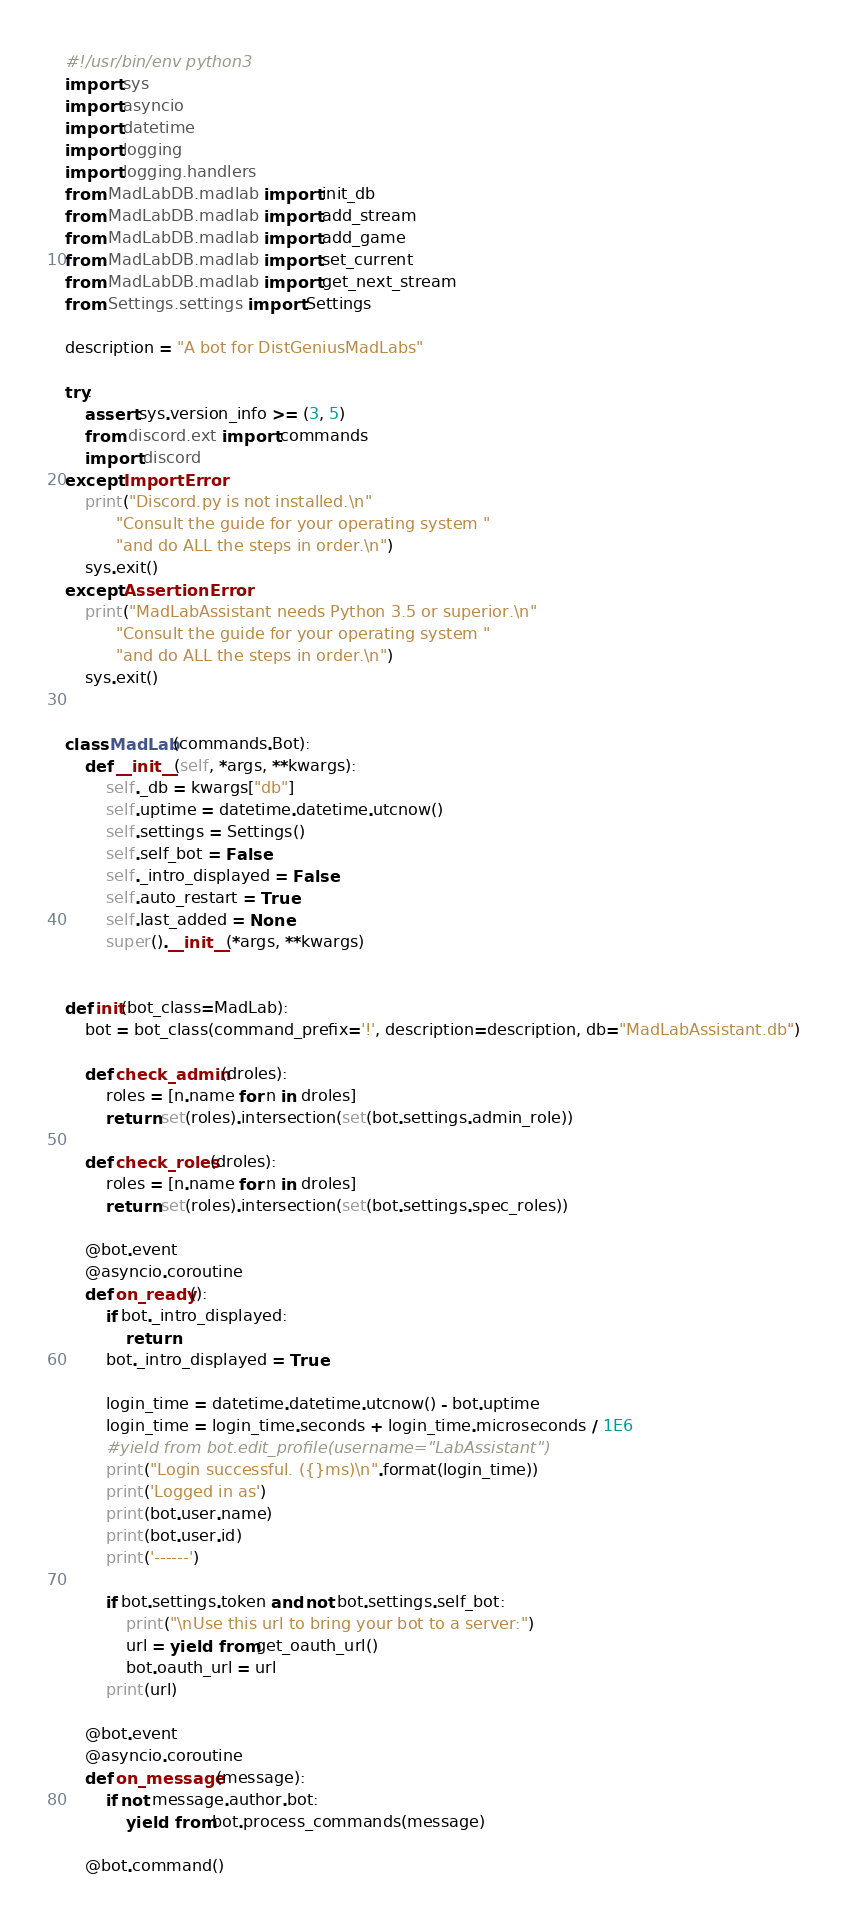<code> <loc_0><loc_0><loc_500><loc_500><_Python_>#!/usr/bin/env python3
import sys
import asyncio
import datetime
import logging
import logging.handlers
from MadLabDB.madlab import init_db
from MadLabDB.madlab import add_stream
from MadLabDB.madlab import add_game
from MadLabDB.madlab import set_current
from MadLabDB.madlab import get_next_stream
from Settings.settings import Settings

description = "A bot for DistGeniusMadLabs"

try:
    assert sys.version_info >= (3, 5)
    from discord.ext import commands
    import discord
except ImportError:
    print("Discord.py is not installed.\n"
          "Consult the guide for your operating system "
          "and do ALL the steps in order.\n")
    sys.exit()
except AssertionError:
    print("MadLabAssistant needs Python 3.5 or superior.\n"
          "Consult the guide for your operating system "
          "and do ALL the steps in order.\n")
    sys.exit()


class MadLab(commands.Bot):
    def __init__(self, *args, **kwargs):
        self._db = kwargs["db"]
        self.uptime = datetime.datetime.utcnow()
        self.settings = Settings()
        self.self_bot = False
        self._intro_displayed = False
        self.auto_restart = True
        self.last_added = None
        super().__init__(*args, **kwargs)


def init(bot_class=MadLab):
    bot = bot_class(command_prefix='!', description=description, db="MadLabAssistant.db")

    def check_admin(droles):
        roles = [n.name for n in droles]
        return set(roles).intersection(set(bot.settings.admin_role))

    def check_roles(droles):
        roles = [n.name for n in droles]
        return set(roles).intersection(set(bot.settings.spec_roles))

    @bot.event
    @asyncio.coroutine
    def on_ready():
        if bot._intro_displayed:
            return
        bot._intro_displayed = True

        login_time = datetime.datetime.utcnow() - bot.uptime
        login_time = login_time.seconds + login_time.microseconds / 1E6
        #yield from bot.edit_profile(username="LabAssistant")
        print("Login successful. ({}ms)\n".format(login_time))
        print('Logged in as')
        print(bot.user.name)
        print(bot.user.id)
        print('------')

        if bot.settings.token and not bot.settings.self_bot:
            print("\nUse this url to bring your bot to a server:")
            url = yield from get_oauth_url()
            bot.oauth_url = url
        print(url)

    @bot.event
    @asyncio.coroutine
    def on_message(message):
        if not message.author.bot:
            yield from bot.process_commands(message)

    @bot.command()</code> 